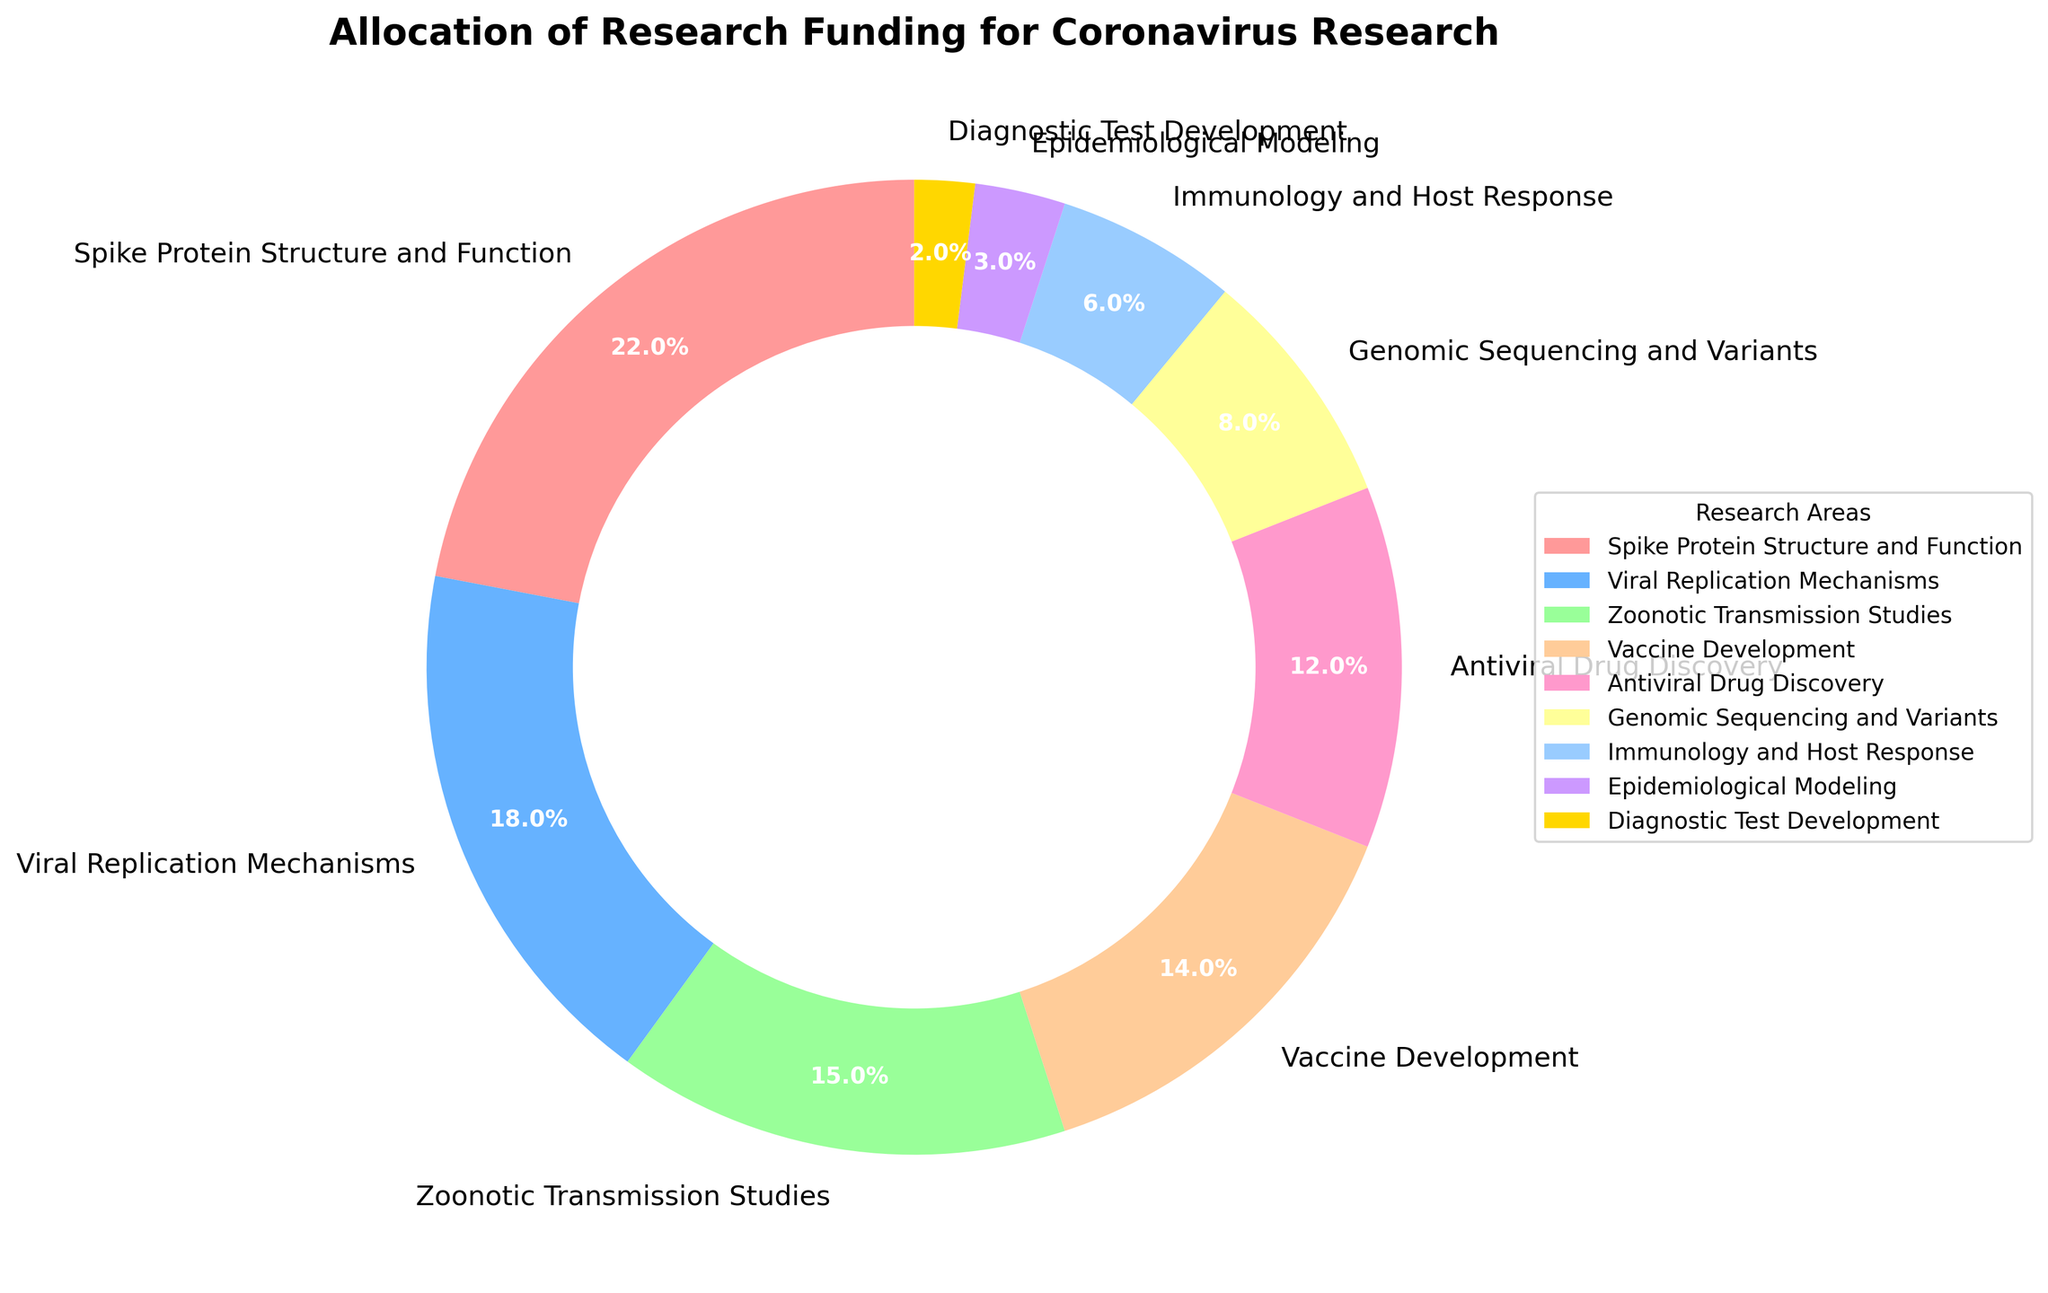What percentage of the funding is allocated to Spike Protein Structure and Function? The section labeled "Spike Protein Structure and Function" shows a percentage value. From the pie chart, we can directly read this percentage.
Answer: 22% Which research area receives the least amount of funding? The smallest section in the pie chart represents the research area with the least funding. The label for this section identifies the research area.
Answer: Diagnostic Test Development What is the combined funding percentage for Vaccine Development and Antiviral Drug Discovery? The sections labeled "Vaccine Development" and "Antiviral Drug Discovery" show their respective percentages. Add these percentages together. Vaccine Development: 14%, Antiviral Drug Discovery: 12%, combined = 14% + 12%.
Answer: 26% Which has more funding: Viral Replication Mechanisms or Epidemiological Modeling? Compare the sections labeled "Viral Replication Mechanisms" and "Epidemiological Modeling" based on their percentages. Viral Replication Mechanisms: 18%, Epidemiological Modeling: 3%.
Answer: Viral Replication Mechanisms How much more funding is allocated to Zoonotic Transmission Studies compared to Immunology and Host Response? Find the percentages for both "Zoonotic Transmission Studies" and "Immunology and Host Response". Subtract the smaller percentage from the larger percentage. Zoonotic Transmission Studies: 15%, Immunology and Host Response: 6%, difference = 15% - 6%.
Answer: 9% What funding percentage is allocated to Genomic Sequencing and Variants? Identify the section labeled "Genomic Sequencing and Variants" in the pie chart and directly read its percentage.
Answer: 8% Rank the top three research areas in terms of funding allocation. Observe the pie chart and list the three sections with the highest funding percentages. These are "Spike Protein Structure and Function", "Viral Replication Mechanisms", and "Zoonotic Transmission Studies" in descending order of percentage.
Answer: Spike Protein Structure and Function, Viral Replication Mechanisms, Zoonotic Transmission Studies What is the total funding percentage allocated to the areas of Immunology and Host Response, Epidemiological Modeling, and Diagnostic Test Development? Add together the percentages for "Immunology and Host Response" (6%), "Epidemiological Modeling" (3%), and "Diagnostic Test Development" (2%). Sum = 6% + 3% + 2%.
Answer: 11% What color represents the Vaccine Development section in the chart? Look at the section labeled "Vaccine Development" and observe the color used for it in the pie chart.
Answer: Light Orange If we consider only the top four research areas by funding, what is their combined funding percentage? Sum the percentages of the top four research areas: "Spike Protein Structure and Function" (22%), "Viral Replication Mechanisms" (18%), "Zoonotic Transmission Studies" (15%), and "Vaccine Development" (14%). Sum = 22% + 18% + 15% + 14%.
Answer: 69% 